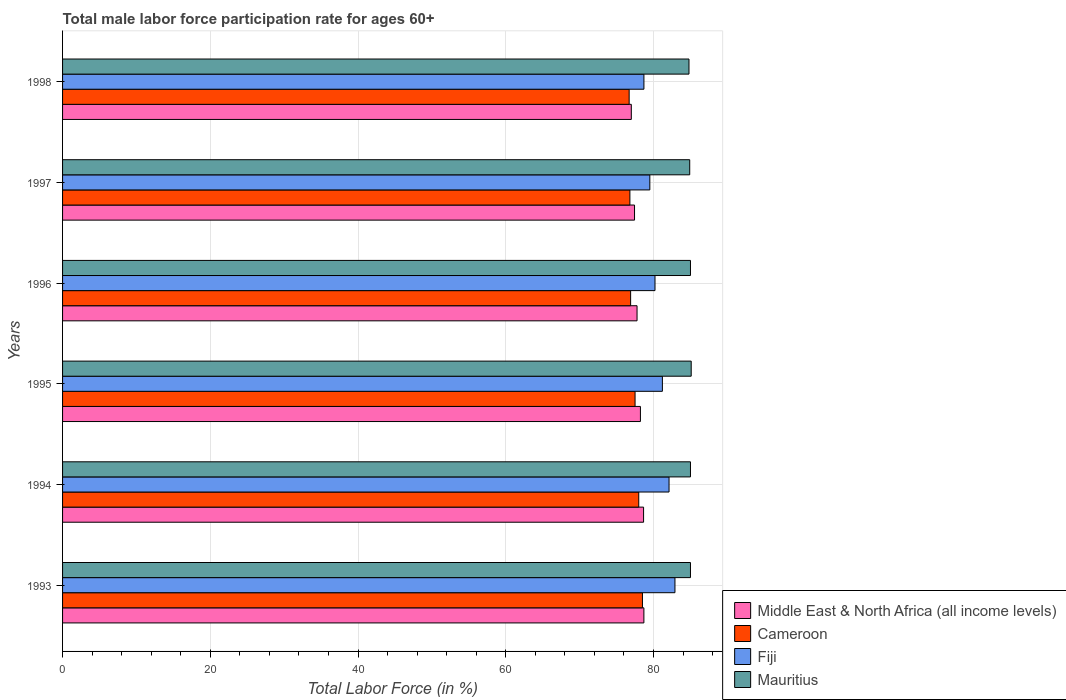How many different coloured bars are there?
Ensure brevity in your answer.  4. How many groups of bars are there?
Ensure brevity in your answer.  6. Are the number of bars per tick equal to the number of legend labels?
Give a very brief answer. Yes. Are the number of bars on each tick of the Y-axis equal?
Your response must be concise. Yes. How many bars are there on the 2nd tick from the top?
Your answer should be compact. 4. How many bars are there on the 2nd tick from the bottom?
Ensure brevity in your answer.  4. In how many cases, is the number of bars for a given year not equal to the number of legend labels?
Provide a succinct answer. 0. What is the male labor force participation rate in Fiji in 1994?
Ensure brevity in your answer.  82.1. Across all years, what is the maximum male labor force participation rate in Cameroon?
Your answer should be very brief. 78.5. Across all years, what is the minimum male labor force participation rate in Middle East & North Africa (all income levels)?
Your response must be concise. 76.99. What is the total male labor force participation rate in Middle East & North Africa (all income levels) in the graph?
Offer a terse response. 467.76. What is the difference between the male labor force participation rate in Mauritius in 1994 and that in 1995?
Your answer should be very brief. -0.1. What is the difference between the male labor force participation rate in Fiji in 1994 and the male labor force participation rate in Mauritius in 1996?
Ensure brevity in your answer.  -2.9. What is the average male labor force participation rate in Fiji per year?
Your answer should be very brief. 80.77. In the year 1996, what is the difference between the male labor force participation rate in Cameroon and male labor force participation rate in Middle East & North Africa (all income levels)?
Make the answer very short. -0.87. In how many years, is the male labor force participation rate in Middle East & North Africa (all income levels) greater than 84 %?
Offer a terse response. 0. What is the ratio of the male labor force participation rate in Middle East & North Africa (all income levels) in 1995 to that in 1998?
Your response must be concise. 1.02. What is the difference between the highest and the lowest male labor force participation rate in Middle East & North Africa (all income levels)?
Ensure brevity in your answer.  1.7. In how many years, is the male labor force participation rate in Mauritius greater than the average male labor force participation rate in Mauritius taken over all years?
Make the answer very short. 4. What does the 4th bar from the top in 1995 represents?
Your response must be concise. Middle East & North Africa (all income levels). What does the 2nd bar from the bottom in 1993 represents?
Give a very brief answer. Cameroon. Are all the bars in the graph horizontal?
Keep it short and to the point. Yes. How many years are there in the graph?
Make the answer very short. 6. What is the difference between two consecutive major ticks on the X-axis?
Make the answer very short. 20. Are the values on the major ticks of X-axis written in scientific E-notation?
Your answer should be very brief. No. Does the graph contain grids?
Your answer should be compact. Yes. Where does the legend appear in the graph?
Ensure brevity in your answer.  Bottom right. How many legend labels are there?
Your response must be concise. 4. How are the legend labels stacked?
Your answer should be very brief. Vertical. What is the title of the graph?
Offer a terse response. Total male labor force participation rate for ages 60+. Does "Germany" appear as one of the legend labels in the graph?
Your answer should be compact. No. What is the Total Labor Force (in %) in Middle East & North Africa (all income levels) in 1993?
Your response must be concise. 78.7. What is the Total Labor Force (in %) of Cameroon in 1993?
Keep it short and to the point. 78.5. What is the Total Labor Force (in %) in Fiji in 1993?
Offer a terse response. 82.9. What is the Total Labor Force (in %) of Mauritius in 1993?
Ensure brevity in your answer.  85. What is the Total Labor Force (in %) of Middle East & North Africa (all income levels) in 1994?
Give a very brief answer. 78.65. What is the Total Labor Force (in %) in Fiji in 1994?
Give a very brief answer. 82.1. What is the Total Labor Force (in %) of Middle East & North Africa (all income levels) in 1995?
Offer a very short reply. 78.23. What is the Total Labor Force (in %) of Cameroon in 1995?
Your response must be concise. 77.5. What is the Total Labor Force (in %) in Fiji in 1995?
Your answer should be very brief. 81.2. What is the Total Labor Force (in %) of Mauritius in 1995?
Keep it short and to the point. 85.1. What is the Total Labor Force (in %) of Middle East & North Africa (all income levels) in 1996?
Offer a very short reply. 77.77. What is the Total Labor Force (in %) in Cameroon in 1996?
Your response must be concise. 76.9. What is the Total Labor Force (in %) in Fiji in 1996?
Provide a short and direct response. 80.2. What is the Total Labor Force (in %) of Mauritius in 1996?
Your response must be concise. 85. What is the Total Labor Force (in %) of Middle East & North Africa (all income levels) in 1997?
Make the answer very short. 77.43. What is the Total Labor Force (in %) in Cameroon in 1997?
Provide a short and direct response. 76.8. What is the Total Labor Force (in %) in Fiji in 1997?
Provide a succinct answer. 79.5. What is the Total Labor Force (in %) of Mauritius in 1997?
Give a very brief answer. 84.9. What is the Total Labor Force (in %) of Middle East & North Africa (all income levels) in 1998?
Provide a short and direct response. 76.99. What is the Total Labor Force (in %) of Cameroon in 1998?
Keep it short and to the point. 76.7. What is the Total Labor Force (in %) in Fiji in 1998?
Your response must be concise. 78.7. What is the Total Labor Force (in %) of Mauritius in 1998?
Give a very brief answer. 84.8. Across all years, what is the maximum Total Labor Force (in %) of Middle East & North Africa (all income levels)?
Your response must be concise. 78.7. Across all years, what is the maximum Total Labor Force (in %) in Cameroon?
Provide a short and direct response. 78.5. Across all years, what is the maximum Total Labor Force (in %) of Fiji?
Ensure brevity in your answer.  82.9. Across all years, what is the maximum Total Labor Force (in %) in Mauritius?
Your answer should be very brief. 85.1. Across all years, what is the minimum Total Labor Force (in %) in Middle East & North Africa (all income levels)?
Your response must be concise. 76.99. Across all years, what is the minimum Total Labor Force (in %) of Cameroon?
Provide a short and direct response. 76.7. Across all years, what is the minimum Total Labor Force (in %) in Fiji?
Provide a short and direct response. 78.7. Across all years, what is the minimum Total Labor Force (in %) of Mauritius?
Provide a short and direct response. 84.8. What is the total Total Labor Force (in %) of Middle East & North Africa (all income levels) in the graph?
Your answer should be very brief. 467.76. What is the total Total Labor Force (in %) of Cameroon in the graph?
Offer a terse response. 464.4. What is the total Total Labor Force (in %) of Fiji in the graph?
Provide a short and direct response. 484.6. What is the total Total Labor Force (in %) of Mauritius in the graph?
Your answer should be very brief. 509.8. What is the difference between the Total Labor Force (in %) in Middle East & North Africa (all income levels) in 1993 and that in 1994?
Ensure brevity in your answer.  0.04. What is the difference between the Total Labor Force (in %) in Cameroon in 1993 and that in 1994?
Offer a very short reply. 0.5. What is the difference between the Total Labor Force (in %) of Middle East & North Africa (all income levels) in 1993 and that in 1995?
Ensure brevity in your answer.  0.47. What is the difference between the Total Labor Force (in %) in Cameroon in 1993 and that in 1995?
Keep it short and to the point. 1. What is the difference between the Total Labor Force (in %) in Fiji in 1993 and that in 1995?
Offer a terse response. 1.7. What is the difference between the Total Labor Force (in %) in Mauritius in 1993 and that in 1995?
Provide a short and direct response. -0.1. What is the difference between the Total Labor Force (in %) in Middle East & North Africa (all income levels) in 1993 and that in 1996?
Your answer should be compact. 0.93. What is the difference between the Total Labor Force (in %) in Cameroon in 1993 and that in 1996?
Offer a very short reply. 1.6. What is the difference between the Total Labor Force (in %) in Fiji in 1993 and that in 1996?
Make the answer very short. 2.7. What is the difference between the Total Labor Force (in %) in Mauritius in 1993 and that in 1996?
Your response must be concise. 0. What is the difference between the Total Labor Force (in %) of Middle East & North Africa (all income levels) in 1993 and that in 1997?
Make the answer very short. 1.27. What is the difference between the Total Labor Force (in %) of Cameroon in 1993 and that in 1997?
Keep it short and to the point. 1.7. What is the difference between the Total Labor Force (in %) of Mauritius in 1993 and that in 1997?
Give a very brief answer. 0.1. What is the difference between the Total Labor Force (in %) of Middle East & North Africa (all income levels) in 1993 and that in 1998?
Ensure brevity in your answer.  1.7. What is the difference between the Total Labor Force (in %) in Fiji in 1993 and that in 1998?
Give a very brief answer. 4.2. What is the difference between the Total Labor Force (in %) of Mauritius in 1993 and that in 1998?
Make the answer very short. 0.2. What is the difference between the Total Labor Force (in %) of Middle East & North Africa (all income levels) in 1994 and that in 1995?
Your answer should be very brief. 0.43. What is the difference between the Total Labor Force (in %) in Cameroon in 1994 and that in 1995?
Give a very brief answer. 0.5. What is the difference between the Total Labor Force (in %) of Fiji in 1994 and that in 1995?
Provide a succinct answer. 0.9. What is the difference between the Total Labor Force (in %) in Middle East & North Africa (all income levels) in 1994 and that in 1996?
Keep it short and to the point. 0.88. What is the difference between the Total Labor Force (in %) of Cameroon in 1994 and that in 1996?
Your answer should be compact. 1.1. What is the difference between the Total Labor Force (in %) of Fiji in 1994 and that in 1996?
Give a very brief answer. 1.9. What is the difference between the Total Labor Force (in %) of Middle East & North Africa (all income levels) in 1994 and that in 1997?
Your answer should be very brief. 1.23. What is the difference between the Total Labor Force (in %) in Cameroon in 1994 and that in 1997?
Provide a succinct answer. 1.2. What is the difference between the Total Labor Force (in %) of Fiji in 1994 and that in 1997?
Give a very brief answer. 2.6. What is the difference between the Total Labor Force (in %) in Mauritius in 1994 and that in 1997?
Your answer should be compact. 0.1. What is the difference between the Total Labor Force (in %) of Middle East & North Africa (all income levels) in 1994 and that in 1998?
Make the answer very short. 1.66. What is the difference between the Total Labor Force (in %) of Cameroon in 1994 and that in 1998?
Your answer should be compact. 1.3. What is the difference between the Total Labor Force (in %) in Mauritius in 1994 and that in 1998?
Make the answer very short. 0.2. What is the difference between the Total Labor Force (in %) in Middle East & North Africa (all income levels) in 1995 and that in 1996?
Keep it short and to the point. 0.46. What is the difference between the Total Labor Force (in %) of Cameroon in 1995 and that in 1996?
Your answer should be very brief. 0.6. What is the difference between the Total Labor Force (in %) of Fiji in 1995 and that in 1996?
Provide a short and direct response. 1. What is the difference between the Total Labor Force (in %) of Mauritius in 1995 and that in 1996?
Give a very brief answer. 0.1. What is the difference between the Total Labor Force (in %) in Middle East & North Africa (all income levels) in 1995 and that in 1997?
Offer a very short reply. 0.8. What is the difference between the Total Labor Force (in %) of Cameroon in 1995 and that in 1997?
Your answer should be compact. 0.7. What is the difference between the Total Labor Force (in %) of Middle East & North Africa (all income levels) in 1995 and that in 1998?
Offer a terse response. 1.23. What is the difference between the Total Labor Force (in %) of Cameroon in 1995 and that in 1998?
Your answer should be very brief. 0.8. What is the difference between the Total Labor Force (in %) in Fiji in 1995 and that in 1998?
Your answer should be compact. 2.5. What is the difference between the Total Labor Force (in %) in Mauritius in 1995 and that in 1998?
Your response must be concise. 0.3. What is the difference between the Total Labor Force (in %) of Middle East & North Africa (all income levels) in 1996 and that in 1997?
Your answer should be compact. 0.34. What is the difference between the Total Labor Force (in %) of Fiji in 1996 and that in 1997?
Offer a very short reply. 0.7. What is the difference between the Total Labor Force (in %) in Mauritius in 1996 and that in 1997?
Give a very brief answer. 0.1. What is the difference between the Total Labor Force (in %) of Middle East & North Africa (all income levels) in 1996 and that in 1998?
Make the answer very short. 0.78. What is the difference between the Total Labor Force (in %) in Mauritius in 1996 and that in 1998?
Offer a terse response. 0.2. What is the difference between the Total Labor Force (in %) in Middle East & North Africa (all income levels) in 1997 and that in 1998?
Ensure brevity in your answer.  0.44. What is the difference between the Total Labor Force (in %) of Cameroon in 1997 and that in 1998?
Your response must be concise. 0.1. What is the difference between the Total Labor Force (in %) in Middle East & North Africa (all income levels) in 1993 and the Total Labor Force (in %) in Cameroon in 1994?
Your answer should be very brief. 0.7. What is the difference between the Total Labor Force (in %) of Middle East & North Africa (all income levels) in 1993 and the Total Labor Force (in %) of Fiji in 1994?
Offer a very short reply. -3.4. What is the difference between the Total Labor Force (in %) of Middle East & North Africa (all income levels) in 1993 and the Total Labor Force (in %) of Mauritius in 1994?
Provide a short and direct response. -6.3. What is the difference between the Total Labor Force (in %) of Cameroon in 1993 and the Total Labor Force (in %) of Mauritius in 1994?
Your answer should be compact. -6.5. What is the difference between the Total Labor Force (in %) of Middle East & North Africa (all income levels) in 1993 and the Total Labor Force (in %) of Cameroon in 1995?
Your response must be concise. 1.2. What is the difference between the Total Labor Force (in %) in Middle East & North Africa (all income levels) in 1993 and the Total Labor Force (in %) in Fiji in 1995?
Offer a terse response. -2.5. What is the difference between the Total Labor Force (in %) in Middle East & North Africa (all income levels) in 1993 and the Total Labor Force (in %) in Mauritius in 1995?
Offer a very short reply. -6.4. What is the difference between the Total Labor Force (in %) of Cameroon in 1993 and the Total Labor Force (in %) of Fiji in 1995?
Offer a very short reply. -2.7. What is the difference between the Total Labor Force (in %) in Fiji in 1993 and the Total Labor Force (in %) in Mauritius in 1995?
Keep it short and to the point. -2.2. What is the difference between the Total Labor Force (in %) of Middle East & North Africa (all income levels) in 1993 and the Total Labor Force (in %) of Cameroon in 1996?
Your response must be concise. 1.8. What is the difference between the Total Labor Force (in %) of Middle East & North Africa (all income levels) in 1993 and the Total Labor Force (in %) of Fiji in 1996?
Your answer should be compact. -1.5. What is the difference between the Total Labor Force (in %) of Middle East & North Africa (all income levels) in 1993 and the Total Labor Force (in %) of Mauritius in 1996?
Provide a short and direct response. -6.3. What is the difference between the Total Labor Force (in %) of Cameroon in 1993 and the Total Labor Force (in %) of Mauritius in 1996?
Your response must be concise. -6.5. What is the difference between the Total Labor Force (in %) in Fiji in 1993 and the Total Labor Force (in %) in Mauritius in 1996?
Ensure brevity in your answer.  -2.1. What is the difference between the Total Labor Force (in %) in Middle East & North Africa (all income levels) in 1993 and the Total Labor Force (in %) in Cameroon in 1997?
Your answer should be very brief. 1.9. What is the difference between the Total Labor Force (in %) of Middle East & North Africa (all income levels) in 1993 and the Total Labor Force (in %) of Fiji in 1997?
Offer a terse response. -0.8. What is the difference between the Total Labor Force (in %) of Middle East & North Africa (all income levels) in 1993 and the Total Labor Force (in %) of Mauritius in 1997?
Offer a terse response. -6.2. What is the difference between the Total Labor Force (in %) of Cameroon in 1993 and the Total Labor Force (in %) of Fiji in 1997?
Offer a terse response. -1. What is the difference between the Total Labor Force (in %) in Middle East & North Africa (all income levels) in 1993 and the Total Labor Force (in %) in Cameroon in 1998?
Provide a succinct answer. 2. What is the difference between the Total Labor Force (in %) of Middle East & North Africa (all income levels) in 1993 and the Total Labor Force (in %) of Fiji in 1998?
Provide a succinct answer. -0. What is the difference between the Total Labor Force (in %) in Middle East & North Africa (all income levels) in 1993 and the Total Labor Force (in %) in Mauritius in 1998?
Your response must be concise. -6.1. What is the difference between the Total Labor Force (in %) in Cameroon in 1993 and the Total Labor Force (in %) in Fiji in 1998?
Offer a terse response. -0.2. What is the difference between the Total Labor Force (in %) of Middle East & North Africa (all income levels) in 1994 and the Total Labor Force (in %) of Cameroon in 1995?
Ensure brevity in your answer.  1.15. What is the difference between the Total Labor Force (in %) in Middle East & North Africa (all income levels) in 1994 and the Total Labor Force (in %) in Fiji in 1995?
Keep it short and to the point. -2.55. What is the difference between the Total Labor Force (in %) of Middle East & North Africa (all income levels) in 1994 and the Total Labor Force (in %) of Mauritius in 1995?
Make the answer very short. -6.45. What is the difference between the Total Labor Force (in %) of Middle East & North Africa (all income levels) in 1994 and the Total Labor Force (in %) of Cameroon in 1996?
Your response must be concise. 1.75. What is the difference between the Total Labor Force (in %) in Middle East & North Africa (all income levels) in 1994 and the Total Labor Force (in %) in Fiji in 1996?
Provide a short and direct response. -1.55. What is the difference between the Total Labor Force (in %) of Middle East & North Africa (all income levels) in 1994 and the Total Labor Force (in %) of Mauritius in 1996?
Your answer should be very brief. -6.35. What is the difference between the Total Labor Force (in %) in Cameroon in 1994 and the Total Labor Force (in %) in Fiji in 1996?
Offer a terse response. -2.2. What is the difference between the Total Labor Force (in %) of Middle East & North Africa (all income levels) in 1994 and the Total Labor Force (in %) of Cameroon in 1997?
Ensure brevity in your answer.  1.85. What is the difference between the Total Labor Force (in %) of Middle East & North Africa (all income levels) in 1994 and the Total Labor Force (in %) of Fiji in 1997?
Give a very brief answer. -0.85. What is the difference between the Total Labor Force (in %) in Middle East & North Africa (all income levels) in 1994 and the Total Labor Force (in %) in Mauritius in 1997?
Offer a very short reply. -6.25. What is the difference between the Total Labor Force (in %) in Cameroon in 1994 and the Total Labor Force (in %) in Mauritius in 1997?
Ensure brevity in your answer.  -6.9. What is the difference between the Total Labor Force (in %) of Middle East & North Africa (all income levels) in 1994 and the Total Labor Force (in %) of Cameroon in 1998?
Make the answer very short. 1.95. What is the difference between the Total Labor Force (in %) of Middle East & North Africa (all income levels) in 1994 and the Total Labor Force (in %) of Fiji in 1998?
Provide a short and direct response. -0.05. What is the difference between the Total Labor Force (in %) in Middle East & North Africa (all income levels) in 1994 and the Total Labor Force (in %) in Mauritius in 1998?
Your response must be concise. -6.15. What is the difference between the Total Labor Force (in %) in Middle East & North Africa (all income levels) in 1995 and the Total Labor Force (in %) in Cameroon in 1996?
Offer a terse response. 1.33. What is the difference between the Total Labor Force (in %) of Middle East & North Africa (all income levels) in 1995 and the Total Labor Force (in %) of Fiji in 1996?
Provide a succinct answer. -1.97. What is the difference between the Total Labor Force (in %) of Middle East & North Africa (all income levels) in 1995 and the Total Labor Force (in %) of Mauritius in 1996?
Ensure brevity in your answer.  -6.77. What is the difference between the Total Labor Force (in %) in Cameroon in 1995 and the Total Labor Force (in %) in Fiji in 1996?
Provide a short and direct response. -2.7. What is the difference between the Total Labor Force (in %) in Middle East & North Africa (all income levels) in 1995 and the Total Labor Force (in %) in Cameroon in 1997?
Offer a terse response. 1.43. What is the difference between the Total Labor Force (in %) of Middle East & North Africa (all income levels) in 1995 and the Total Labor Force (in %) of Fiji in 1997?
Provide a short and direct response. -1.27. What is the difference between the Total Labor Force (in %) in Middle East & North Africa (all income levels) in 1995 and the Total Labor Force (in %) in Mauritius in 1997?
Offer a very short reply. -6.67. What is the difference between the Total Labor Force (in %) in Cameroon in 1995 and the Total Labor Force (in %) in Mauritius in 1997?
Make the answer very short. -7.4. What is the difference between the Total Labor Force (in %) of Middle East & North Africa (all income levels) in 1995 and the Total Labor Force (in %) of Cameroon in 1998?
Offer a very short reply. 1.53. What is the difference between the Total Labor Force (in %) in Middle East & North Africa (all income levels) in 1995 and the Total Labor Force (in %) in Fiji in 1998?
Ensure brevity in your answer.  -0.47. What is the difference between the Total Labor Force (in %) in Middle East & North Africa (all income levels) in 1995 and the Total Labor Force (in %) in Mauritius in 1998?
Your answer should be compact. -6.57. What is the difference between the Total Labor Force (in %) in Cameroon in 1995 and the Total Labor Force (in %) in Fiji in 1998?
Provide a short and direct response. -1.2. What is the difference between the Total Labor Force (in %) in Cameroon in 1995 and the Total Labor Force (in %) in Mauritius in 1998?
Keep it short and to the point. -7.3. What is the difference between the Total Labor Force (in %) in Middle East & North Africa (all income levels) in 1996 and the Total Labor Force (in %) in Cameroon in 1997?
Your answer should be compact. 0.97. What is the difference between the Total Labor Force (in %) of Middle East & North Africa (all income levels) in 1996 and the Total Labor Force (in %) of Fiji in 1997?
Your response must be concise. -1.73. What is the difference between the Total Labor Force (in %) of Middle East & North Africa (all income levels) in 1996 and the Total Labor Force (in %) of Mauritius in 1997?
Provide a short and direct response. -7.13. What is the difference between the Total Labor Force (in %) in Cameroon in 1996 and the Total Labor Force (in %) in Mauritius in 1997?
Your answer should be very brief. -8. What is the difference between the Total Labor Force (in %) of Fiji in 1996 and the Total Labor Force (in %) of Mauritius in 1997?
Your response must be concise. -4.7. What is the difference between the Total Labor Force (in %) of Middle East & North Africa (all income levels) in 1996 and the Total Labor Force (in %) of Cameroon in 1998?
Your response must be concise. 1.07. What is the difference between the Total Labor Force (in %) of Middle East & North Africa (all income levels) in 1996 and the Total Labor Force (in %) of Fiji in 1998?
Offer a terse response. -0.93. What is the difference between the Total Labor Force (in %) of Middle East & North Africa (all income levels) in 1996 and the Total Labor Force (in %) of Mauritius in 1998?
Keep it short and to the point. -7.03. What is the difference between the Total Labor Force (in %) in Middle East & North Africa (all income levels) in 1997 and the Total Labor Force (in %) in Cameroon in 1998?
Your response must be concise. 0.73. What is the difference between the Total Labor Force (in %) of Middle East & North Africa (all income levels) in 1997 and the Total Labor Force (in %) of Fiji in 1998?
Your response must be concise. -1.27. What is the difference between the Total Labor Force (in %) of Middle East & North Africa (all income levels) in 1997 and the Total Labor Force (in %) of Mauritius in 1998?
Make the answer very short. -7.37. What is the difference between the Total Labor Force (in %) in Fiji in 1997 and the Total Labor Force (in %) in Mauritius in 1998?
Your answer should be compact. -5.3. What is the average Total Labor Force (in %) of Middle East & North Africa (all income levels) per year?
Provide a succinct answer. 77.96. What is the average Total Labor Force (in %) of Cameroon per year?
Make the answer very short. 77.4. What is the average Total Labor Force (in %) in Fiji per year?
Your response must be concise. 80.77. What is the average Total Labor Force (in %) of Mauritius per year?
Your response must be concise. 84.97. In the year 1993, what is the difference between the Total Labor Force (in %) of Middle East & North Africa (all income levels) and Total Labor Force (in %) of Cameroon?
Provide a short and direct response. 0.2. In the year 1993, what is the difference between the Total Labor Force (in %) in Middle East & North Africa (all income levels) and Total Labor Force (in %) in Fiji?
Your answer should be compact. -4.2. In the year 1993, what is the difference between the Total Labor Force (in %) of Middle East & North Africa (all income levels) and Total Labor Force (in %) of Mauritius?
Ensure brevity in your answer.  -6.3. In the year 1993, what is the difference between the Total Labor Force (in %) in Cameroon and Total Labor Force (in %) in Fiji?
Provide a short and direct response. -4.4. In the year 1993, what is the difference between the Total Labor Force (in %) in Cameroon and Total Labor Force (in %) in Mauritius?
Ensure brevity in your answer.  -6.5. In the year 1994, what is the difference between the Total Labor Force (in %) in Middle East & North Africa (all income levels) and Total Labor Force (in %) in Cameroon?
Provide a succinct answer. 0.65. In the year 1994, what is the difference between the Total Labor Force (in %) of Middle East & North Africa (all income levels) and Total Labor Force (in %) of Fiji?
Make the answer very short. -3.45. In the year 1994, what is the difference between the Total Labor Force (in %) of Middle East & North Africa (all income levels) and Total Labor Force (in %) of Mauritius?
Make the answer very short. -6.35. In the year 1994, what is the difference between the Total Labor Force (in %) in Cameroon and Total Labor Force (in %) in Fiji?
Make the answer very short. -4.1. In the year 1995, what is the difference between the Total Labor Force (in %) of Middle East & North Africa (all income levels) and Total Labor Force (in %) of Cameroon?
Provide a succinct answer. 0.73. In the year 1995, what is the difference between the Total Labor Force (in %) in Middle East & North Africa (all income levels) and Total Labor Force (in %) in Fiji?
Make the answer very short. -2.97. In the year 1995, what is the difference between the Total Labor Force (in %) of Middle East & North Africa (all income levels) and Total Labor Force (in %) of Mauritius?
Offer a terse response. -6.87. In the year 1995, what is the difference between the Total Labor Force (in %) of Cameroon and Total Labor Force (in %) of Mauritius?
Make the answer very short. -7.6. In the year 1995, what is the difference between the Total Labor Force (in %) of Fiji and Total Labor Force (in %) of Mauritius?
Provide a short and direct response. -3.9. In the year 1996, what is the difference between the Total Labor Force (in %) of Middle East & North Africa (all income levels) and Total Labor Force (in %) of Cameroon?
Make the answer very short. 0.87. In the year 1996, what is the difference between the Total Labor Force (in %) of Middle East & North Africa (all income levels) and Total Labor Force (in %) of Fiji?
Ensure brevity in your answer.  -2.43. In the year 1996, what is the difference between the Total Labor Force (in %) of Middle East & North Africa (all income levels) and Total Labor Force (in %) of Mauritius?
Offer a terse response. -7.23. In the year 1996, what is the difference between the Total Labor Force (in %) in Cameroon and Total Labor Force (in %) in Mauritius?
Provide a short and direct response. -8.1. In the year 1996, what is the difference between the Total Labor Force (in %) in Fiji and Total Labor Force (in %) in Mauritius?
Provide a succinct answer. -4.8. In the year 1997, what is the difference between the Total Labor Force (in %) in Middle East & North Africa (all income levels) and Total Labor Force (in %) in Cameroon?
Give a very brief answer. 0.63. In the year 1997, what is the difference between the Total Labor Force (in %) in Middle East & North Africa (all income levels) and Total Labor Force (in %) in Fiji?
Your answer should be compact. -2.07. In the year 1997, what is the difference between the Total Labor Force (in %) of Middle East & North Africa (all income levels) and Total Labor Force (in %) of Mauritius?
Provide a short and direct response. -7.47. In the year 1997, what is the difference between the Total Labor Force (in %) in Fiji and Total Labor Force (in %) in Mauritius?
Your answer should be compact. -5.4. In the year 1998, what is the difference between the Total Labor Force (in %) in Middle East & North Africa (all income levels) and Total Labor Force (in %) in Cameroon?
Ensure brevity in your answer.  0.29. In the year 1998, what is the difference between the Total Labor Force (in %) of Middle East & North Africa (all income levels) and Total Labor Force (in %) of Fiji?
Give a very brief answer. -1.71. In the year 1998, what is the difference between the Total Labor Force (in %) of Middle East & North Africa (all income levels) and Total Labor Force (in %) of Mauritius?
Offer a very short reply. -7.81. What is the ratio of the Total Labor Force (in %) of Cameroon in 1993 to that in 1994?
Give a very brief answer. 1.01. What is the ratio of the Total Labor Force (in %) in Fiji in 1993 to that in 1994?
Provide a short and direct response. 1.01. What is the ratio of the Total Labor Force (in %) of Cameroon in 1993 to that in 1995?
Give a very brief answer. 1.01. What is the ratio of the Total Labor Force (in %) of Fiji in 1993 to that in 1995?
Make the answer very short. 1.02. What is the ratio of the Total Labor Force (in %) in Middle East & North Africa (all income levels) in 1993 to that in 1996?
Keep it short and to the point. 1.01. What is the ratio of the Total Labor Force (in %) of Cameroon in 1993 to that in 1996?
Keep it short and to the point. 1.02. What is the ratio of the Total Labor Force (in %) of Fiji in 1993 to that in 1996?
Provide a succinct answer. 1.03. What is the ratio of the Total Labor Force (in %) in Middle East & North Africa (all income levels) in 1993 to that in 1997?
Make the answer very short. 1.02. What is the ratio of the Total Labor Force (in %) in Cameroon in 1993 to that in 1997?
Offer a terse response. 1.02. What is the ratio of the Total Labor Force (in %) in Fiji in 1993 to that in 1997?
Your answer should be very brief. 1.04. What is the ratio of the Total Labor Force (in %) in Middle East & North Africa (all income levels) in 1993 to that in 1998?
Provide a succinct answer. 1.02. What is the ratio of the Total Labor Force (in %) in Cameroon in 1993 to that in 1998?
Give a very brief answer. 1.02. What is the ratio of the Total Labor Force (in %) in Fiji in 1993 to that in 1998?
Your response must be concise. 1.05. What is the ratio of the Total Labor Force (in %) of Middle East & North Africa (all income levels) in 1994 to that in 1995?
Make the answer very short. 1.01. What is the ratio of the Total Labor Force (in %) of Fiji in 1994 to that in 1995?
Your response must be concise. 1.01. What is the ratio of the Total Labor Force (in %) in Middle East & North Africa (all income levels) in 1994 to that in 1996?
Provide a short and direct response. 1.01. What is the ratio of the Total Labor Force (in %) in Cameroon in 1994 to that in 1996?
Your answer should be very brief. 1.01. What is the ratio of the Total Labor Force (in %) of Fiji in 1994 to that in 1996?
Offer a terse response. 1.02. What is the ratio of the Total Labor Force (in %) of Middle East & North Africa (all income levels) in 1994 to that in 1997?
Your answer should be compact. 1.02. What is the ratio of the Total Labor Force (in %) of Cameroon in 1994 to that in 1997?
Give a very brief answer. 1.02. What is the ratio of the Total Labor Force (in %) in Fiji in 1994 to that in 1997?
Offer a terse response. 1.03. What is the ratio of the Total Labor Force (in %) in Mauritius in 1994 to that in 1997?
Your answer should be very brief. 1. What is the ratio of the Total Labor Force (in %) of Middle East & North Africa (all income levels) in 1994 to that in 1998?
Offer a very short reply. 1.02. What is the ratio of the Total Labor Force (in %) in Cameroon in 1994 to that in 1998?
Offer a very short reply. 1.02. What is the ratio of the Total Labor Force (in %) of Fiji in 1994 to that in 1998?
Your answer should be very brief. 1.04. What is the ratio of the Total Labor Force (in %) in Mauritius in 1994 to that in 1998?
Offer a very short reply. 1. What is the ratio of the Total Labor Force (in %) in Middle East & North Africa (all income levels) in 1995 to that in 1996?
Keep it short and to the point. 1.01. What is the ratio of the Total Labor Force (in %) in Cameroon in 1995 to that in 1996?
Make the answer very short. 1.01. What is the ratio of the Total Labor Force (in %) of Fiji in 1995 to that in 1996?
Provide a succinct answer. 1.01. What is the ratio of the Total Labor Force (in %) of Middle East & North Africa (all income levels) in 1995 to that in 1997?
Ensure brevity in your answer.  1.01. What is the ratio of the Total Labor Force (in %) in Cameroon in 1995 to that in 1997?
Make the answer very short. 1.01. What is the ratio of the Total Labor Force (in %) in Fiji in 1995 to that in 1997?
Your answer should be compact. 1.02. What is the ratio of the Total Labor Force (in %) in Middle East & North Africa (all income levels) in 1995 to that in 1998?
Make the answer very short. 1.02. What is the ratio of the Total Labor Force (in %) of Cameroon in 1995 to that in 1998?
Provide a short and direct response. 1.01. What is the ratio of the Total Labor Force (in %) of Fiji in 1995 to that in 1998?
Offer a terse response. 1.03. What is the ratio of the Total Labor Force (in %) in Cameroon in 1996 to that in 1997?
Ensure brevity in your answer.  1. What is the ratio of the Total Labor Force (in %) in Fiji in 1996 to that in 1997?
Ensure brevity in your answer.  1.01. What is the ratio of the Total Labor Force (in %) in Mauritius in 1996 to that in 1997?
Your response must be concise. 1. What is the ratio of the Total Labor Force (in %) of Middle East & North Africa (all income levels) in 1996 to that in 1998?
Offer a very short reply. 1.01. What is the ratio of the Total Labor Force (in %) of Cameroon in 1996 to that in 1998?
Keep it short and to the point. 1. What is the ratio of the Total Labor Force (in %) of Fiji in 1996 to that in 1998?
Your answer should be compact. 1.02. What is the ratio of the Total Labor Force (in %) in Fiji in 1997 to that in 1998?
Offer a terse response. 1.01. What is the ratio of the Total Labor Force (in %) of Mauritius in 1997 to that in 1998?
Provide a short and direct response. 1. What is the difference between the highest and the second highest Total Labor Force (in %) in Middle East & North Africa (all income levels)?
Provide a succinct answer. 0.04. What is the difference between the highest and the lowest Total Labor Force (in %) of Middle East & North Africa (all income levels)?
Offer a very short reply. 1.7. 